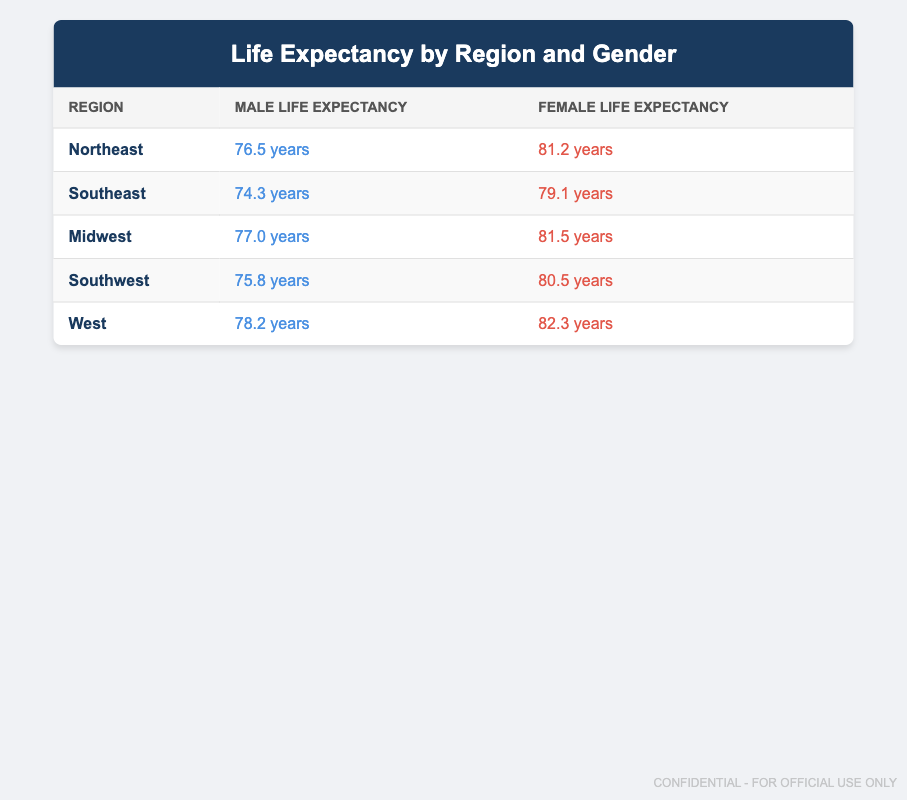What is the life expectancy of males in the Northeast region? According to the table, the life expectancy of males in the Northeast region is specifically listed as 76.5 years.
Answer: 76.5 years Which region has the highest female life expectancy? By examining the table, we can see that the West region has the highest female life expectancy at 82.3 years.
Answer: West What is the difference in life expectancy between males and females in the Midwest? The male life expectancy in the Midwest is 77.0 years, while the female's is 81.5 years. The difference is calculated as 81.5 - 77.0 = 4.5 years.
Answer: 4.5 years Is the life expectancy of males in the Southeast region higher than that in the Southwest region? The life expectancy of males in the Southeast is 74.3 years while in the Southwest, it is 75.8 years. Since 74.3 is less than 75.8, the statement is false.
Answer: No What is the average life expectancy of males across all regions? Adding the male life expectancies: 76.5 + 74.3 + 77.0 + 75.8 + 78.2 = 381.8 years. There are 5 regions, so the average is 381.8 / 5 = 76.36 years.
Answer: 76.36 years In which region do females have a life expectancy of 80.5 years? By looking at the table, we can find that the life expectancy for females in the Southwest region is 80.5 years.
Answer: Southwest Do males in the West region have a higher life expectancy than females in the Southeast region? The male life expectancy in the West is 78.2 years and the female life expectancy in the Southeast is 79.1 years. Since 78.2 is less than 79.1, the statement is false.
Answer: No What is the sum of female life expectancies in the Northeast and Midwest regions? The female life expectancy in the Northeast is 81.2 years and in the Midwest is 81.5 years. Their sum is 81.2 + 81.5 = 162.7 years.
Answer: 162.7 years 